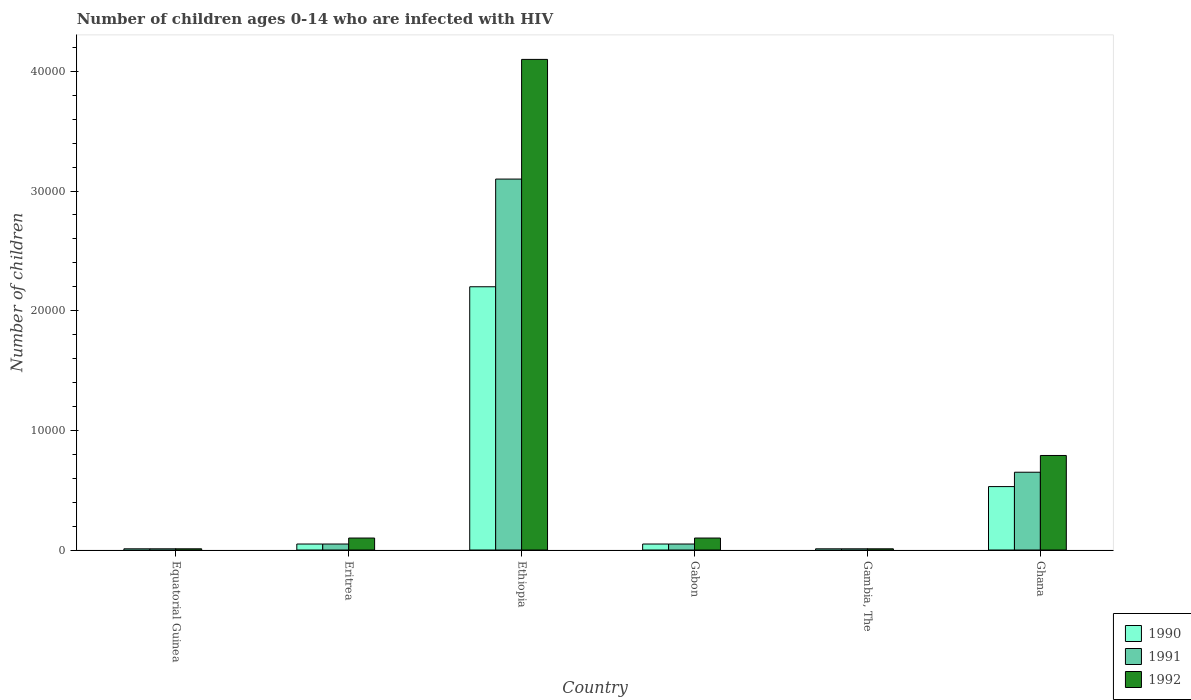How many different coloured bars are there?
Provide a succinct answer. 3. Are the number of bars on each tick of the X-axis equal?
Your response must be concise. Yes. How many bars are there on the 2nd tick from the left?
Make the answer very short. 3. What is the label of the 1st group of bars from the left?
Ensure brevity in your answer.  Equatorial Guinea. What is the number of HIV infected children in 1990 in Eritrea?
Your answer should be compact. 500. Across all countries, what is the maximum number of HIV infected children in 1991?
Provide a short and direct response. 3.10e+04. Across all countries, what is the minimum number of HIV infected children in 1991?
Keep it short and to the point. 100. In which country was the number of HIV infected children in 1992 maximum?
Your response must be concise. Ethiopia. In which country was the number of HIV infected children in 1990 minimum?
Your answer should be very brief. Equatorial Guinea. What is the total number of HIV infected children in 1991 in the graph?
Your answer should be compact. 3.87e+04. What is the difference between the number of HIV infected children in 1990 in Equatorial Guinea and that in Gambia, The?
Provide a succinct answer. 0. What is the difference between the number of HIV infected children in 1991 in Equatorial Guinea and the number of HIV infected children in 1990 in Eritrea?
Ensure brevity in your answer.  -400. What is the average number of HIV infected children in 1992 per country?
Your answer should be very brief. 8516.67. What is the difference between the number of HIV infected children of/in 1991 and number of HIV infected children of/in 1992 in Ghana?
Your response must be concise. -1400. What is the ratio of the number of HIV infected children in 1990 in Ethiopia to that in Gabon?
Make the answer very short. 44. What is the difference between the highest and the second highest number of HIV infected children in 1990?
Your answer should be compact. 1.67e+04. What is the difference between the highest and the lowest number of HIV infected children in 1990?
Your answer should be compact. 2.19e+04. What does the 3rd bar from the left in Equatorial Guinea represents?
Your response must be concise. 1992. How many countries are there in the graph?
Keep it short and to the point. 6. What is the difference between two consecutive major ticks on the Y-axis?
Provide a short and direct response. 10000. Does the graph contain any zero values?
Provide a succinct answer. No. How many legend labels are there?
Your answer should be very brief. 3. What is the title of the graph?
Your answer should be very brief. Number of children ages 0-14 who are infected with HIV. What is the label or title of the Y-axis?
Offer a very short reply. Number of children. What is the Number of children of 1991 in Equatorial Guinea?
Your answer should be compact. 100. What is the Number of children of 1992 in Equatorial Guinea?
Ensure brevity in your answer.  100. What is the Number of children in 1990 in Ethiopia?
Provide a succinct answer. 2.20e+04. What is the Number of children in 1991 in Ethiopia?
Make the answer very short. 3.10e+04. What is the Number of children of 1992 in Ethiopia?
Provide a succinct answer. 4.10e+04. What is the Number of children of 1990 in Gabon?
Provide a succinct answer. 500. What is the Number of children of 1992 in Gabon?
Your answer should be very brief. 1000. What is the Number of children of 1990 in Gambia, The?
Provide a short and direct response. 100. What is the Number of children of 1992 in Gambia, The?
Your answer should be compact. 100. What is the Number of children in 1990 in Ghana?
Give a very brief answer. 5300. What is the Number of children of 1991 in Ghana?
Keep it short and to the point. 6500. What is the Number of children of 1992 in Ghana?
Make the answer very short. 7900. Across all countries, what is the maximum Number of children in 1990?
Provide a succinct answer. 2.20e+04. Across all countries, what is the maximum Number of children in 1991?
Ensure brevity in your answer.  3.10e+04. Across all countries, what is the maximum Number of children in 1992?
Keep it short and to the point. 4.10e+04. Across all countries, what is the minimum Number of children in 1990?
Provide a succinct answer. 100. Across all countries, what is the minimum Number of children in 1992?
Your answer should be compact. 100. What is the total Number of children in 1990 in the graph?
Ensure brevity in your answer.  2.85e+04. What is the total Number of children in 1991 in the graph?
Provide a succinct answer. 3.87e+04. What is the total Number of children in 1992 in the graph?
Offer a terse response. 5.11e+04. What is the difference between the Number of children of 1990 in Equatorial Guinea and that in Eritrea?
Ensure brevity in your answer.  -400. What is the difference between the Number of children in 1991 in Equatorial Guinea and that in Eritrea?
Your response must be concise. -400. What is the difference between the Number of children of 1992 in Equatorial Guinea and that in Eritrea?
Make the answer very short. -900. What is the difference between the Number of children in 1990 in Equatorial Guinea and that in Ethiopia?
Offer a very short reply. -2.19e+04. What is the difference between the Number of children of 1991 in Equatorial Guinea and that in Ethiopia?
Provide a short and direct response. -3.09e+04. What is the difference between the Number of children in 1992 in Equatorial Guinea and that in Ethiopia?
Ensure brevity in your answer.  -4.09e+04. What is the difference between the Number of children in 1990 in Equatorial Guinea and that in Gabon?
Keep it short and to the point. -400. What is the difference between the Number of children of 1991 in Equatorial Guinea and that in Gabon?
Offer a very short reply. -400. What is the difference between the Number of children in 1992 in Equatorial Guinea and that in Gabon?
Give a very brief answer. -900. What is the difference between the Number of children of 1992 in Equatorial Guinea and that in Gambia, The?
Keep it short and to the point. 0. What is the difference between the Number of children of 1990 in Equatorial Guinea and that in Ghana?
Make the answer very short. -5200. What is the difference between the Number of children in 1991 in Equatorial Guinea and that in Ghana?
Provide a succinct answer. -6400. What is the difference between the Number of children in 1992 in Equatorial Guinea and that in Ghana?
Your answer should be compact. -7800. What is the difference between the Number of children in 1990 in Eritrea and that in Ethiopia?
Provide a succinct answer. -2.15e+04. What is the difference between the Number of children of 1991 in Eritrea and that in Ethiopia?
Your answer should be compact. -3.05e+04. What is the difference between the Number of children in 1992 in Eritrea and that in Ethiopia?
Your response must be concise. -4.00e+04. What is the difference between the Number of children of 1990 in Eritrea and that in Gabon?
Give a very brief answer. 0. What is the difference between the Number of children in 1991 in Eritrea and that in Gabon?
Give a very brief answer. 0. What is the difference between the Number of children of 1992 in Eritrea and that in Gabon?
Provide a succinct answer. 0. What is the difference between the Number of children of 1991 in Eritrea and that in Gambia, The?
Your answer should be compact. 400. What is the difference between the Number of children of 1992 in Eritrea and that in Gambia, The?
Ensure brevity in your answer.  900. What is the difference between the Number of children in 1990 in Eritrea and that in Ghana?
Your answer should be compact. -4800. What is the difference between the Number of children of 1991 in Eritrea and that in Ghana?
Your response must be concise. -6000. What is the difference between the Number of children of 1992 in Eritrea and that in Ghana?
Provide a succinct answer. -6900. What is the difference between the Number of children of 1990 in Ethiopia and that in Gabon?
Give a very brief answer. 2.15e+04. What is the difference between the Number of children in 1991 in Ethiopia and that in Gabon?
Provide a succinct answer. 3.05e+04. What is the difference between the Number of children of 1990 in Ethiopia and that in Gambia, The?
Your answer should be compact. 2.19e+04. What is the difference between the Number of children in 1991 in Ethiopia and that in Gambia, The?
Offer a very short reply. 3.09e+04. What is the difference between the Number of children of 1992 in Ethiopia and that in Gambia, The?
Your answer should be compact. 4.09e+04. What is the difference between the Number of children in 1990 in Ethiopia and that in Ghana?
Your response must be concise. 1.67e+04. What is the difference between the Number of children in 1991 in Ethiopia and that in Ghana?
Your response must be concise. 2.45e+04. What is the difference between the Number of children of 1992 in Ethiopia and that in Ghana?
Offer a terse response. 3.31e+04. What is the difference between the Number of children in 1990 in Gabon and that in Gambia, The?
Give a very brief answer. 400. What is the difference between the Number of children in 1992 in Gabon and that in Gambia, The?
Provide a short and direct response. 900. What is the difference between the Number of children of 1990 in Gabon and that in Ghana?
Ensure brevity in your answer.  -4800. What is the difference between the Number of children in 1991 in Gabon and that in Ghana?
Your answer should be compact. -6000. What is the difference between the Number of children of 1992 in Gabon and that in Ghana?
Your answer should be very brief. -6900. What is the difference between the Number of children of 1990 in Gambia, The and that in Ghana?
Provide a short and direct response. -5200. What is the difference between the Number of children of 1991 in Gambia, The and that in Ghana?
Your answer should be compact. -6400. What is the difference between the Number of children of 1992 in Gambia, The and that in Ghana?
Offer a very short reply. -7800. What is the difference between the Number of children in 1990 in Equatorial Guinea and the Number of children in 1991 in Eritrea?
Ensure brevity in your answer.  -400. What is the difference between the Number of children of 1990 in Equatorial Guinea and the Number of children of 1992 in Eritrea?
Give a very brief answer. -900. What is the difference between the Number of children of 1991 in Equatorial Guinea and the Number of children of 1992 in Eritrea?
Offer a terse response. -900. What is the difference between the Number of children in 1990 in Equatorial Guinea and the Number of children in 1991 in Ethiopia?
Your answer should be compact. -3.09e+04. What is the difference between the Number of children in 1990 in Equatorial Guinea and the Number of children in 1992 in Ethiopia?
Keep it short and to the point. -4.09e+04. What is the difference between the Number of children in 1991 in Equatorial Guinea and the Number of children in 1992 in Ethiopia?
Make the answer very short. -4.09e+04. What is the difference between the Number of children in 1990 in Equatorial Guinea and the Number of children in 1991 in Gabon?
Keep it short and to the point. -400. What is the difference between the Number of children of 1990 in Equatorial Guinea and the Number of children of 1992 in Gabon?
Offer a terse response. -900. What is the difference between the Number of children in 1991 in Equatorial Guinea and the Number of children in 1992 in Gabon?
Make the answer very short. -900. What is the difference between the Number of children of 1990 in Equatorial Guinea and the Number of children of 1992 in Gambia, The?
Make the answer very short. 0. What is the difference between the Number of children of 1990 in Equatorial Guinea and the Number of children of 1991 in Ghana?
Your response must be concise. -6400. What is the difference between the Number of children of 1990 in Equatorial Guinea and the Number of children of 1992 in Ghana?
Offer a very short reply. -7800. What is the difference between the Number of children in 1991 in Equatorial Guinea and the Number of children in 1992 in Ghana?
Make the answer very short. -7800. What is the difference between the Number of children of 1990 in Eritrea and the Number of children of 1991 in Ethiopia?
Offer a terse response. -3.05e+04. What is the difference between the Number of children in 1990 in Eritrea and the Number of children in 1992 in Ethiopia?
Give a very brief answer. -4.05e+04. What is the difference between the Number of children in 1991 in Eritrea and the Number of children in 1992 in Ethiopia?
Offer a very short reply. -4.05e+04. What is the difference between the Number of children in 1990 in Eritrea and the Number of children in 1992 in Gabon?
Your answer should be compact. -500. What is the difference between the Number of children of 1991 in Eritrea and the Number of children of 1992 in Gabon?
Your response must be concise. -500. What is the difference between the Number of children of 1990 in Eritrea and the Number of children of 1991 in Gambia, The?
Your answer should be compact. 400. What is the difference between the Number of children of 1990 in Eritrea and the Number of children of 1992 in Gambia, The?
Ensure brevity in your answer.  400. What is the difference between the Number of children in 1990 in Eritrea and the Number of children in 1991 in Ghana?
Your response must be concise. -6000. What is the difference between the Number of children of 1990 in Eritrea and the Number of children of 1992 in Ghana?
Give a very brief answer. -7400. What is the difference between the Number of children in 1991 in Eritrea and the Number of children in 1992 in Ghana?
Your answer should be very brief. -7400. What is the difference between the Number of children of 1990 in Ethiopia and the Number of children of 1991 in Gabon?
Your answer should be compact. 2.15e+04. What is the difference between the Number of children of 1990 in Ethiopia and the Number of children of 1992 in Gabon?
Your answer should be very brief. 2.10e+04. What is the difference between the Number of children of 1990 in Ethiopia and the Number of children of 1991 in Gambia, The?
Offer a terse response. 2.19e+04. What is the difference between the Number of children of 1990 in Ethiopia and the Number of children of 1992 in Gambia, The?
Your answer should be compact. 2.19e+04. What is the difference between the Number of children in 1991 in Ethiopia and the Number of children in 1992 in Gambia, The?
Give a very brief answer. 3.09e+04. What is the difference between the Number of children of 1990 in Ethiopia and the Number of children of 1991 in Ghana?
Give a very brief answer. 1.55e+04. What is the difference between the Number of children of 1990 in Ethiopia and the Number of children of 1992 in Ghana?
Provide a short and direct response. 1.41e+04. What is the difference between the Number of children of 1991 in Ethiopia and the Number of children of 1992 in Ghana?
Your answer should be compact. 2.31e+04. What is the difference between the Number of children of 1990 in Gabon and the Number of children of 1991 in Gambia, The?
Offer a terse response. 400. What is the difference between the Number of children of 1990 in Gabon and the Number of children of 1991 in Ghana?
Offer a terse response. -6000. What is the difference between the Number of children in 1990 in Gabon and the Number of children in 1992 in Ghana?
Offer a terse response. -7400. What is the difference between the Number of children in 1991 in Gabon and the Number of children in 1992 in Ghana?
Offer a very short reply. -7400. What is the difference between the Number of children of 1990 in Gambia, The and the Number of children of 1991 in Ghana?
Your response must be concise. -6400. What is the difference between the Number of children in 1990 in Gambia, The and the Number of children in 1992 in Ghana?
Give a very brief answer. -7800. What is the difference between the Number of children of 1991 in Gambia, The and the Number of children of 1992 in Ghana?
Offer a very short reply. -7800. What is the average Number of children in 1990 per country?
Ensure brevity in your answer.  4750. What is the average Number of children in 1991 per country?
Provide a succinct answer. 6450. What is the average Number of children of 1992 per country?
Provide a short and direct response. 8516.67. What is the difference between the Number of children of 1990 and Number of children of 1991 in Equatorial Guinea?
Provide a short and direct response. 0. What is the difference between the Number of children of 1990 and Number of children of 1992 in Equatorial Guinea?
Give a very brief answer. 0. What is the difference between the Number of children of 1990 and Number of children of 1992 in Eritrea?
Give a very brief answer. -500. What is the difference between the Number of children in 1991 and Number of children in 1992 in Eritrea?
Provide a succinct answer. -500. What is the difference between the Number of children in 1990 and Number of children in 1991 in Ethiopia?
Make the answer very short. -9000. What is the difference between the Number of children in 1990 and Number of children in 1992 in Ethiopia?
Offer a terse response. -1.90e+04. What is the difference between the Number of children of 1990 and Number of children of 1991 in Gabon?
Make the answer very short. 0. What is the difference between the Number of children in 1990 and Number of children in 1992 in Gabon?
Offer a terse response. -500. What is the difference between the Number of children in 1991 and Number of children in 1992 in Gabon?
Your response must be concise. -500. What is the difference between the Number of children of 1990 and Number of children of 1991 in Ghana?
Your answer should be very brief. -1200. What is the difference between the Number of children in 1990 and Number of children in 1992 in Ghana?
Your answer should be compact. -2600. What is the difference between the Number of children in 1991 and Number of children in 1992 in Ghana?
Offer a terse response. -1400. What is the ratio of the Number of children in 1991 in Equatorial Guinea to that in Eritrea?
Ensure brevity in your answer.  0.2. What is the ratio of the Number of children of 1992 in Equatorial Guinea to that in Eritrea?
Make the answer very short. 0.1. What is the ratio of the Number of children in 1990 in Equatorial Guinea to that in Ethiopia?
Make the answer very short. 0. What is the ratio of the Number of children in 1991 in Equatorial Guinea to that in Ethiopia?
Keep it short and to the point. 0. What is the ratio of the Number of children in 1992 in Equatorial Guinea to that in Ethiopia?
Give a very brief answer. 0. What is the ratio of the Number of children of 1990 in Equatorial Guinea to that in Gabon?
Keep it short and to the point. 0.2. What is the ratio of the Number of children in 1992 in Equatorial Guinea to that in Gabon?
Offer a very short reply. 0.1. What is the ratio of the Number of children of 1991 in Equatorial Guinea to that in Gambia, The?
Make the answer very short. 1. What is the ratio of the Number of children of 1992 in Equatorial Guinea to that in Gambia, The?
Your answer should be very brief. 1. What is the ratio of the Number of children of 1990 in Equatorial Guinea to that in Ghana?
Make the answer very short. 0.02. What is the ratio of the Number of children of 1991 in Equatorial Guinea to that in Ghana?
Ensure brevity in your answer.  0.02. What is the ratio of the Number of children of 1992 in Equatorial Guinea to that in Ghana?
Make the answer very short. 0.01. What is the ratio of the Number of children in 1990 in Eritrea to that in Ethiopia?
Keep it short and to the point. 0.02. What is the ratio of the Number of children of 1991 in Eritrea to that in Ethiopia?
Your answer should be very brief. 0.02. What is the ratio of the Number of children of 1992 in Eritrea to that in Ethiopia?
Provide a succinct answer. 0.02. What is the ratio of the Number of children of 1992 in Eritrea to that in Gabon?
Your answer should be very brief. 1. What is the ratio of the Number of children of 1990 in Eritrea to that in Gambia, The?
Offer a terse response. 5. What is the ratio of the Number of children of 1990 in Eritrea to that in Ghana?
Provide a succinct answer. 0.09. What is the ratio of the Number of children of 1991 in Eritrea to that in Ghana?
Provide a short and direct response. 0.08. What is the ratio of the Number of children in 1992 in Eritrea to that in Ghana?
Keep it short and to the point. 0.13. What is the ratio of the Number of children in 1990 in Ethiopia to that in Gabon?
Offer a very short reply. 44. What is the ratio of the Number of children in 1990 in Ethiopia to that in Gambia, The?
Provide a succinct answer. 220. What is the ratio of the Number of children of 1991 in Ethiopia to that in Gambia, The?
Give a very brief answer. 310. What is the ratio of the Number of children of 1992 in Ethiopia to that in Gambia, The?
Keep it short and to the point. 410. What is the ratio of the Number of children in 1990 in Ethiopia to that in Ghana?
Ensure brevity in your answer.  4.15. What is the ratio of the Number of children in 1991 in Ethiopia to that in Ghana?
Provide a short and direct response. 4.77. What is the ratio of the Number of children of 1992 in Ethiopia to that in Ghana?
Your answer should be compact. 5.19. What is the ratio of the Number of children in 1990 in Gabon to that in Gambia, The?
Offer a terse response. 5. What is the ratio of the Number of children of 1992 in Gabon to that in Gambia, The?
Keep it short and to the point. 10. What is the ratio of the Number of children in 1990 in Gabon to that in Ghana?
Make the answer very short. 0.09. What is the ratio of the Number of children of 1991 in Gabon to that in Ghana?
Your answer should be compact. 0.08. What is the ratio of the Number of children of 1992 in Gabon to that in Ghana?
Your answer should be very brief. 0.13. What is the ratio of the Number of children in 1990 in Gambia, The to that in Ghana?
Offer a terse response. 0.02. What is the ratio of the Number of children of 1991 in Gambia, The to that in Ghana?
Keep it short and to the point. 0.02. What is the ratio of the Number of children in 1992 in Gambia, The to that in Ghana?
Your response must be concise. 0.01. What is the difference between the highest and the second highest Number of children of 1990?
Your answer should be very brief. 1.67e+04. What is the difference between the highest and the second highest Number of children in 1991?
Provide a short and direct response. 2.45e+04. What is the difference between the highest and the second highest Number of children in 1992?
Provide a short and direct response. 3.31e+04. What is the difference between the highest and the lowest Number of children of 1990?
Ensure brevity in your answer.  2.19e+04. What is the difference between the highest and the lowest Number of children in 1991?
Give a very brief answer. 3.09e+04. What is the difference between the highest and the lowest Number of children in 1992?
Make the answer very short. 4.09e+04. 